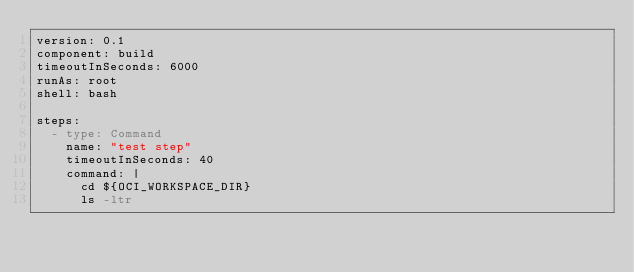<code> <loc_0><loc_0><loc_500><loc_500><_YAML_>version: 0.1
component: build
timeoutInSeconds: 6000
runAs: root
shell: bash

steps:
  - type: Command
    name: "test step"
    timeoutInSeconds: 40
    command: |
      cd ${OCI_WORKSPACE_DIR}
      ls -ltr 
      
  
  </code> 